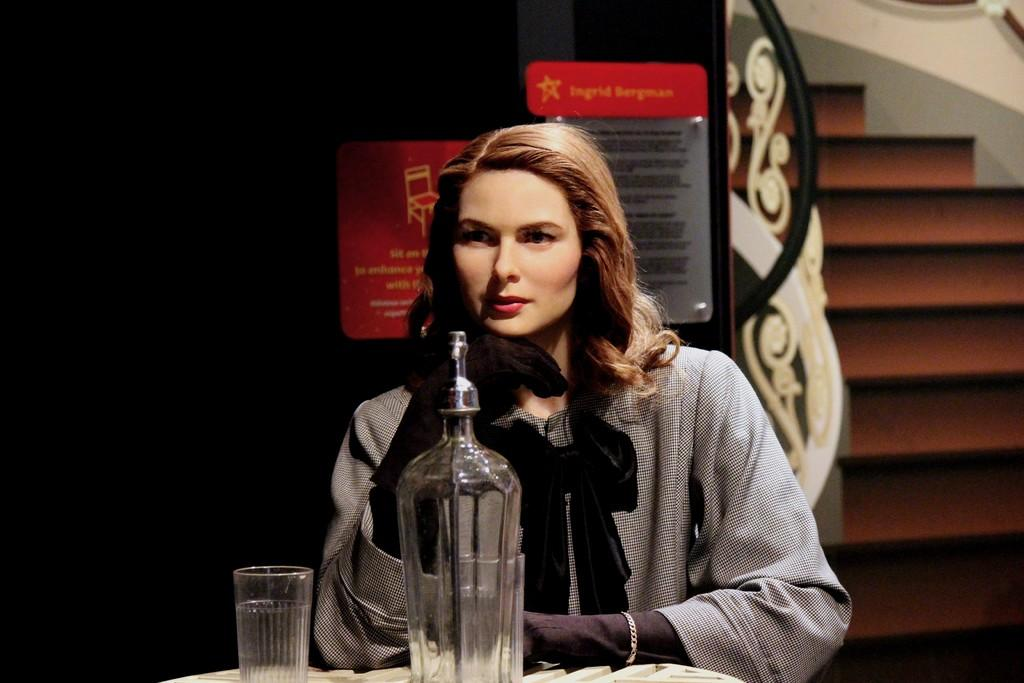Who is present in the image? There is a woman in the image. What is the woman doing in the image? The woman is sitting. What objects can be seen on the table in the image? There is a glass bottle and a glass on a table. What architectural feature is visible behind the woman? There are stairs visible behind the woman. What type of organization is responsible for maintaining the seashore in the image? There is no seashore present in the image, so it is not possible to determine which organization might be responsible for maintaining it. 